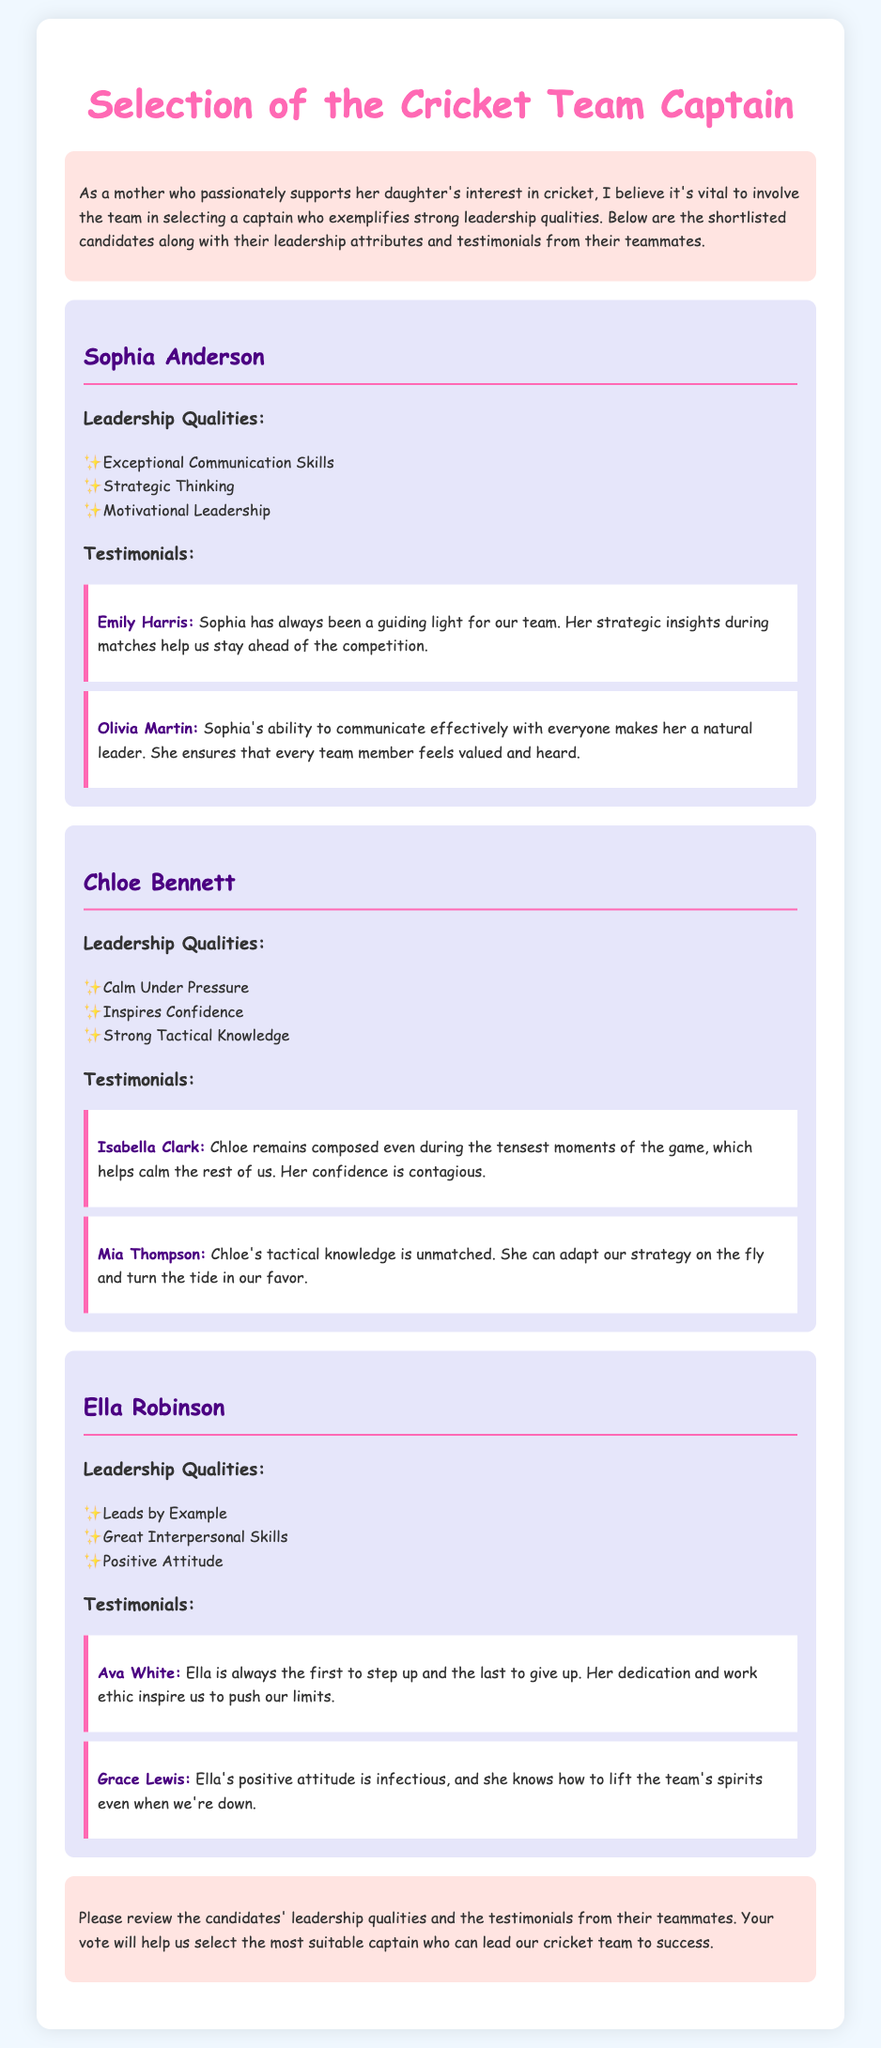What is the title of the document? The title at the top of the document indicates the focus of the ballot for selecting a captain.
Answer: Selection of the Cricket Team Captain Who is one of the testimonials for Sophia Anderson? This question asks for a teammate who provided a testimonial, specifically for Sophia Anderson.
Answer: Emily Harris What quality does Chloe Bennett possess? This question aims to identify one of the leadership qualities attributed to Chloe Bennett.
Answer: Calm Under Pressure How many testimonials are provided for Ella Robinson? This question asks for a count of the testimonials available for Ella Robinson in the document.
Answer: 2 Which quality is associated with motivational leadership? This question is related to identifying the specific leadership quality that reflects the ability to motivate others.
Answer: Sophia Anderson Who claims that Chloe inspires confidence? The question seeks to find the name of the teammate who mentions Chloe's ability to inspire confidence.
Answer: Isabella Clark What describes Ella Robinson's attitude? This question looks for a specific adjective that depicts Ella Robinson's general demeanor within the team.
Answer: Positive What is the name of the candidate who leads by example? This question requires identifying the candidate known for leading by personal example from the content.
Answer: Ella Robinson 